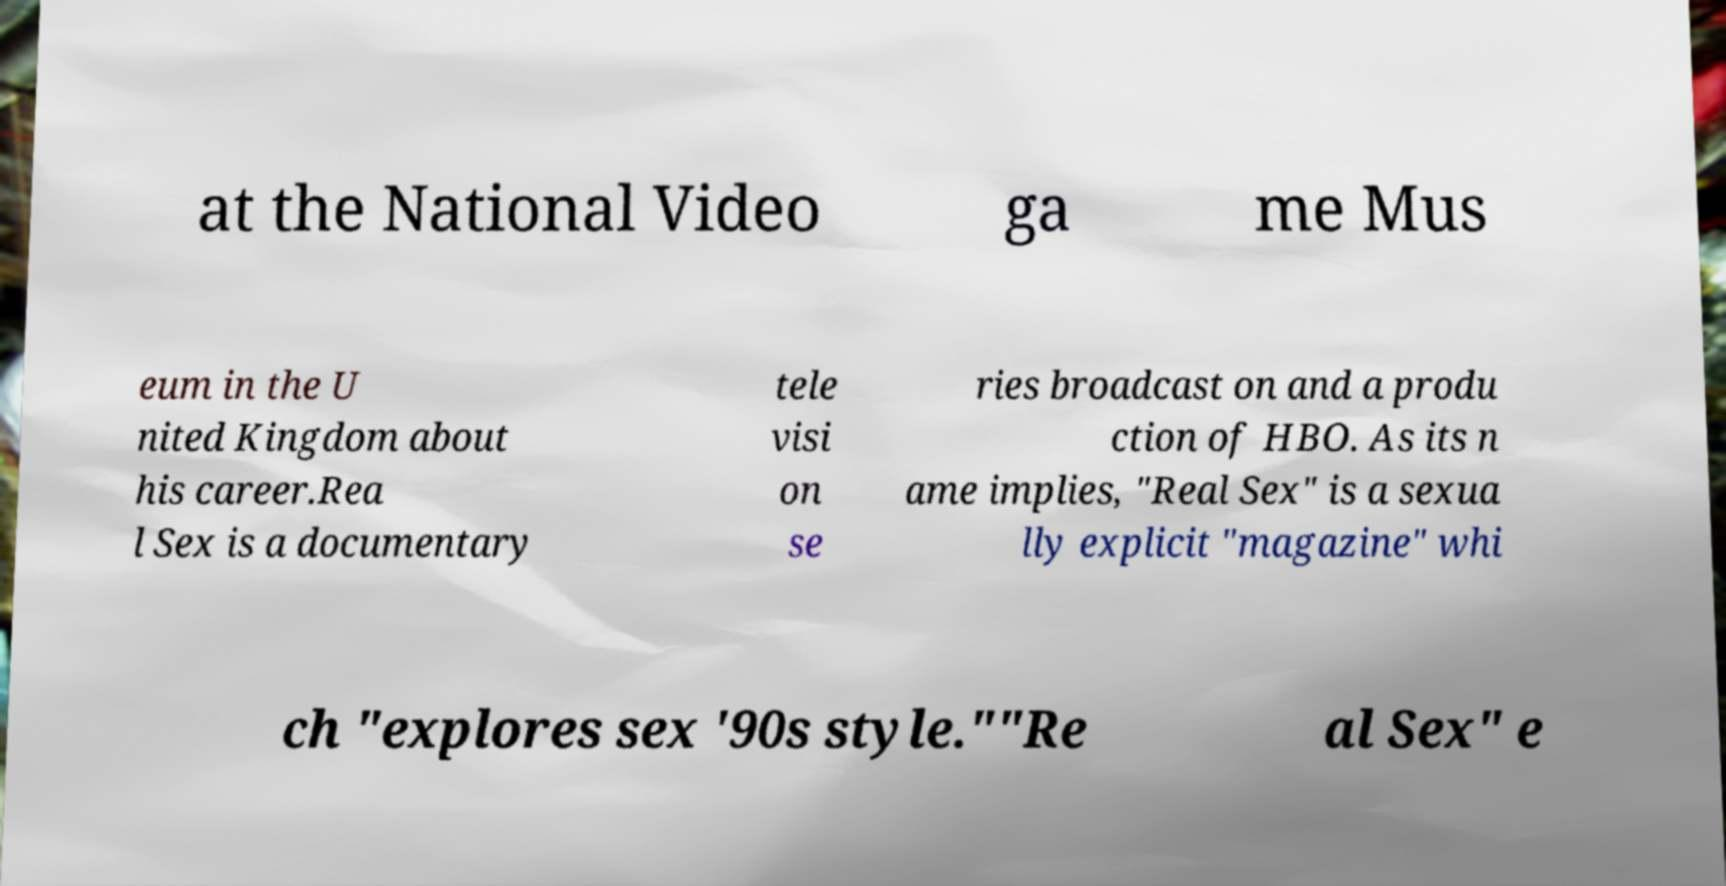Can you read and provide the text displayed in the image?This photo seems to have some interesting text. Can you extract and type it out for me? at the National Video ga me Mus eum in the U nited Kingdom about his career.Rea l Sex is a documentary tele visi on se ries broadcast on and a produ ction of HBO. As its n ame implies, "Real Sex" is a sexua lly explicit "magazine" whi ch "explores sex '90s style.""Re al Sex" e 